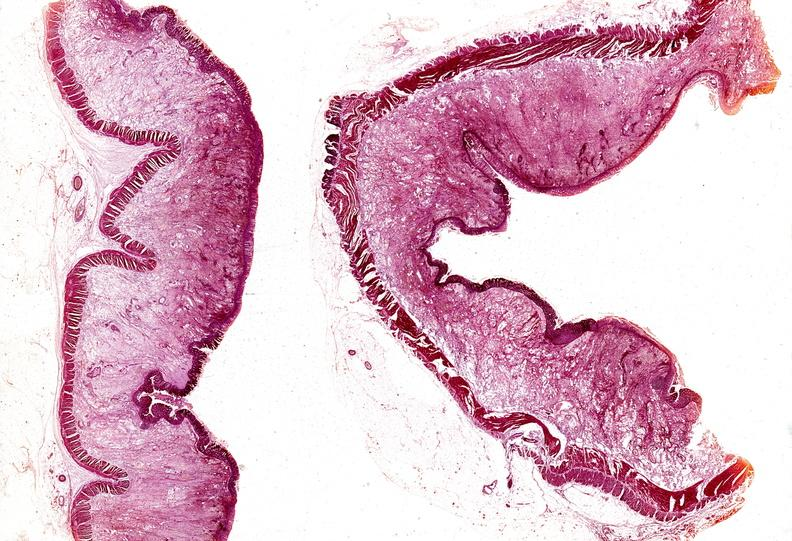what is present?
Answer the question using a single word or phrase. Gastrointestinal 